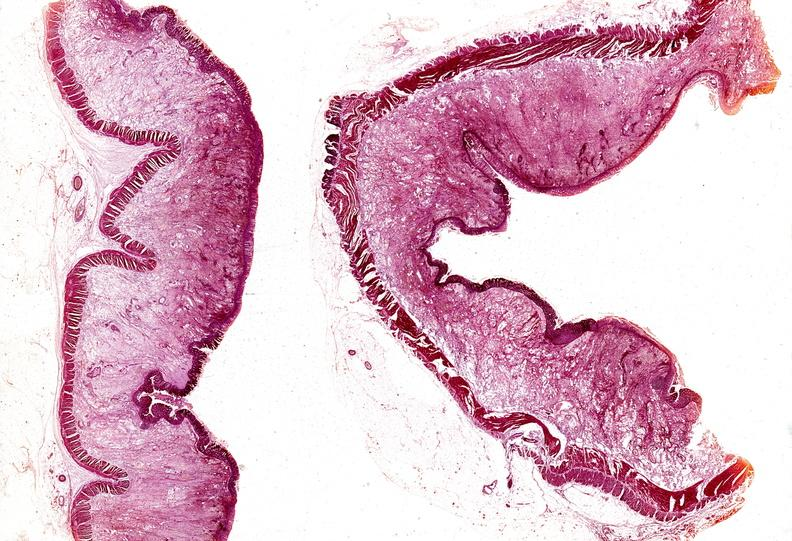what is present?
Answer the question using a single word or phrase. Gastrointestinal 